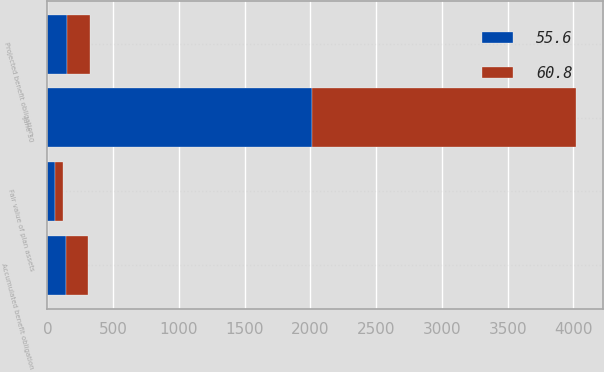Convert chart to OTSL. <chart><loc_0><loc_0><loc_500><loc_500><stacked_bar_chart><ecel><fcel>June 30<fcel>Projected benefit obligation<fcel>Accumulated benefit obligation<fcel>Fair value of plan assets<nl><fcel>60.8<fcel>2012<fcel>171.5<fcel>161.8<fcel>60.8<nl><fcel>55.6<fcel>2011<fcel>150.7<fcel>143.2<fcel>55.6<nl></chart> 